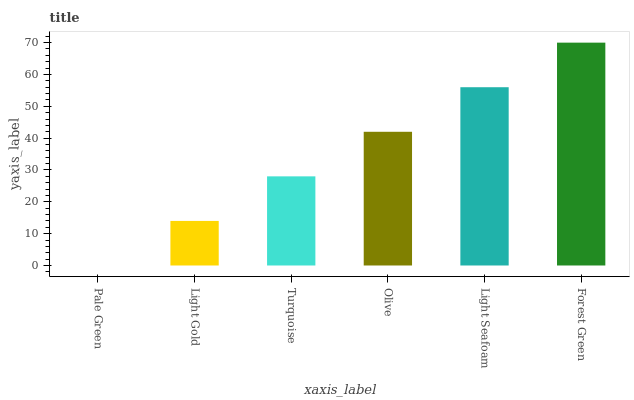Is Pale Green the minimum?
Answer yes or no. Yes. Is Forest Green the maximum?
Answer yes or no. Yes. Is Light Gold the minimum?
Answer yes or no. No. Is Light Gold the maximum?
Answer yes or no. No. Is Light Gold greater than Pale Green?
Answer yes or no. Yes. Is Pale Green less than Light Gold?
Answer yes or no. Yes. Is Pale Green greater than Light Gold?
Answer yes or no. No. Is Light Gold less than Pale Green?
Answer yes or no. No. Is Olive the high median?
Answer yes or no. Yes. Is Turquoise the low median?
Answer yes or no. Yes. Is Forest Green the high median?
Answer yes or no. No. Is Olive the low median?
Answer yes or no. No. 